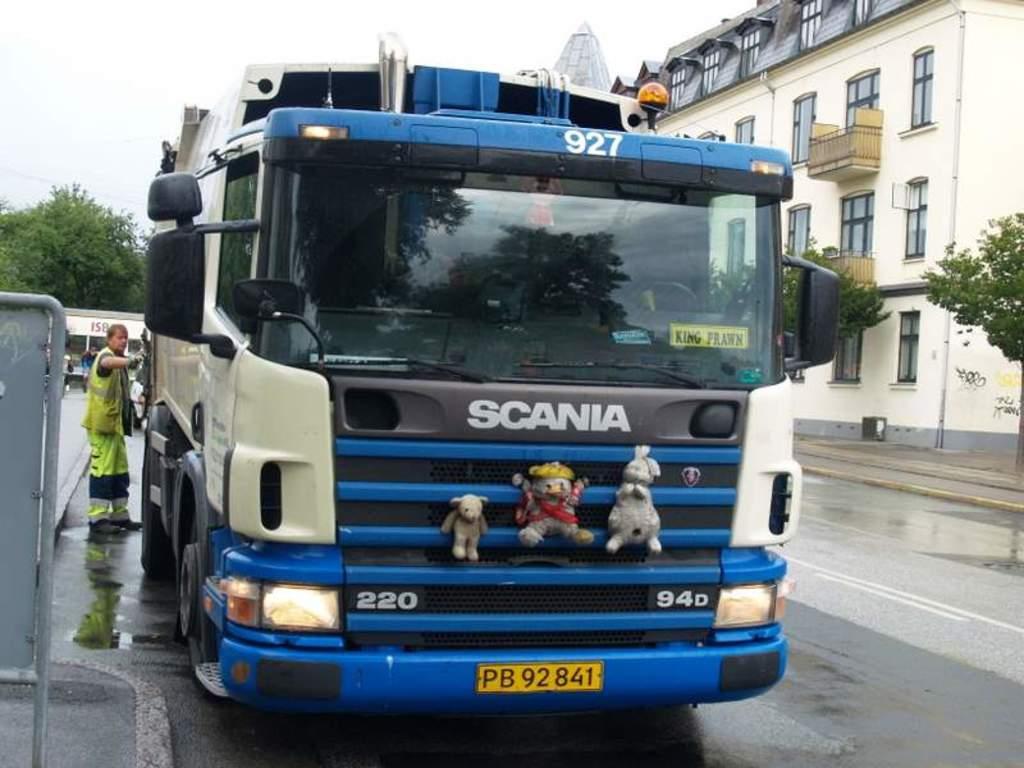How would you summarize this image in a sentence or two? In this image we can see a vehicle on the road and dolls attached to the vehicle and a person standing near the vehicle, there is a metal object on the left side and there are trees in front of the building on the right side of the image and there is a shade, tree and the sky in the background. 